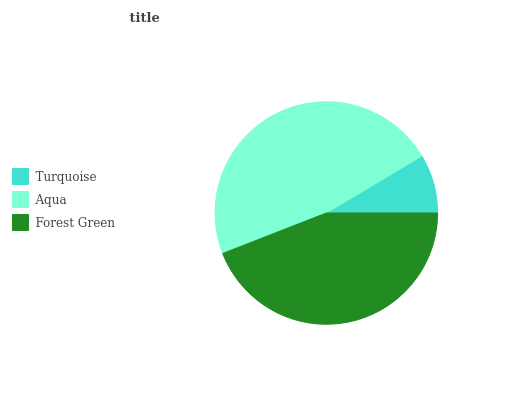Is Turquoise the minimum?
Answer yes or no. Yes. Is Aqua the maximum?
Answer yes or no. Yes. Is Forest Green the minimum?
Answer yes or no. No. Is Forest Green the maximum?
Answer yes or no. No. Is Aqua greater than Forest Green?
Answer yes or no. Yes. Is Forest Green less than Aqua?
Answer yes or no. Yes. Is Forest Green greater than Aqua?
Answer yes or no. No. Is Aqua less than Forest Green?
Answer yes or no. No. Is Forest Green the high median?
Answer yes or no. Yes. Is Forest Green the low median?
Answer yes or no. Yes. Is Turquoise the high median?
Answer yes or no. No. Is Aqua the low median?
Answer yes or no. No. 